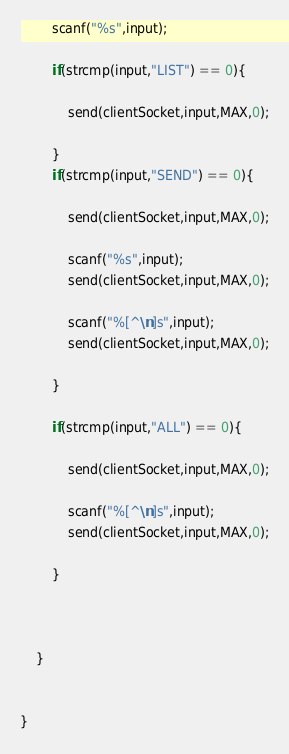<code> <loc_0><loc_0><loc_500><loc_500><_C_>		scanf("%s",input);

		if(strcmp(input,"LIST") == 0){

			send(clientSocket,input,MAX,0);

		}
		if(strcmp(input,"SEND") == 0){

			send(clientSocket,input,MAX,0);
			
			scanf("%s",input);
			send(clientSocket,input,MAX,0);
			
			scanf("%[^\n]s",input);
			send(clientSocket,input,MAX,0);

		}

		if(strcmp(input,"ALL") == 0){

			send(clientSocket,input,MAX,0);
			
			scanf("%[^\n]s",input);
			send(clientSocket,input,MAX,0);

		}



	}


}</code> 